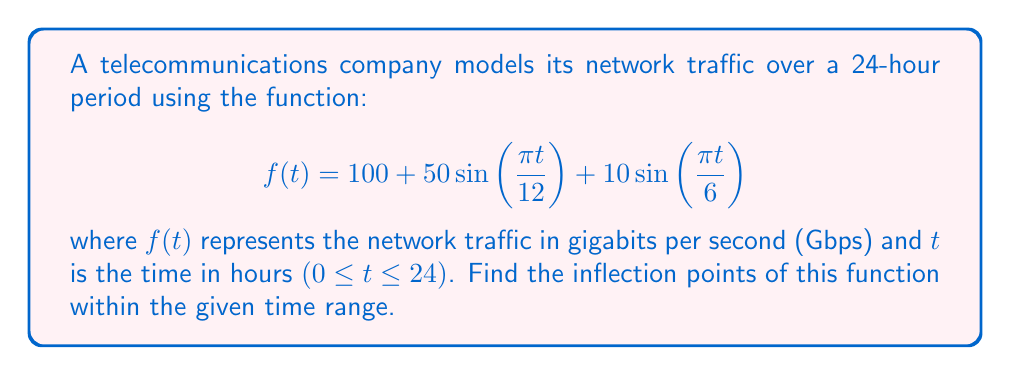Give your solution to this math problem. To find the inflection points, we need to follow these steps:

1) First, calculate the first derivative $f'(t)$:
   $$f'(t) = \frac{50\pi}{12}\cos\left(\frac{\pi t}{12}\right) + \frac{10\pi}{6}\cos\left(\frac{\pi t}{6}\right)$$

2) Then, calculate the second derivative $f''(t)$:
   $$f''(t) = -\frac{50\pi^2}{144}\sin\left(\frac{\pi t}{12}\right) - \frac{10\pi^2}{36}\sin\left(\frac{\pi t}{6}\right)$$

3) Inflection points occur where $f''(t) = 0$. So, we need to solve:
   $$-\frac{50\pi^2}{144}\sin\left(\frac{\pi t}{12}\right) - \frac{10\pi^2}{36}\sin\left(\frac{\pi t}{6}\right) = 0$$

4) Simplify:
   $$-25\sin\left(\frac{\pi t}{12}\right) - 20\sin\left(\frac{\pi t}{6}\right) = 0$$
   $$25\sin\left(\frac{\pi t}{12}\right) = -20\sin\left(\frac{\pi t}{6}\right)$$

5) Using the double angle formula $\sin(2x) = 2\sin(x)\cos(x)$, we can rewrite $\sin(\frac{\pi t}{6})$:
   $$25\sin\left(\frac{\pi t}{12}\right) = -20\left(2\sin\left(\frac{\pi t}{12}\right)\cos\left(\frac{\pi t}{12}\right)\right)$$

6) Simplify:
   $$25\sin\left(\frac{\pi t}{12}\right) = -40\sin\left(\frac{\pi t}{12}\right)\cos\left(\frac{\pi t}{12}\right)$$
   $$25 = -40\cos\left(\frac{\pi t}{12}\right)$$
   $$\cos\left(\frac{\pi t}{12}\right) = -\frac{5}{8}$$

7) Solve for t:
   $$\frac{\pi t}{12} = \arccos\left(-\frac{5}{8}\right) + 2\pi n \text{ or } 2\pi - \arccos\left(-\frac{5}{8}\right) + 2\pi n$$
   $$t = \frac{12}{\pi}\left(\arccos\left(-\frac{5}{8}\right) + 2\pi n\right) \text{ or } \frac{12}{\pi}\left(2\pi - \arccos\left(-\frac{5}{8}\right) + 2\pi n\right)$$

8) The solutions within the range 0 ≤ t ≤ 24 are:
   $$t \approx 3.93 \text{ and } t \approx 15.93$$

These are the inflection points of the function within the given time range.
Answer: The inflection points occur at approximately 3.93 hours and 15.93 hours. 